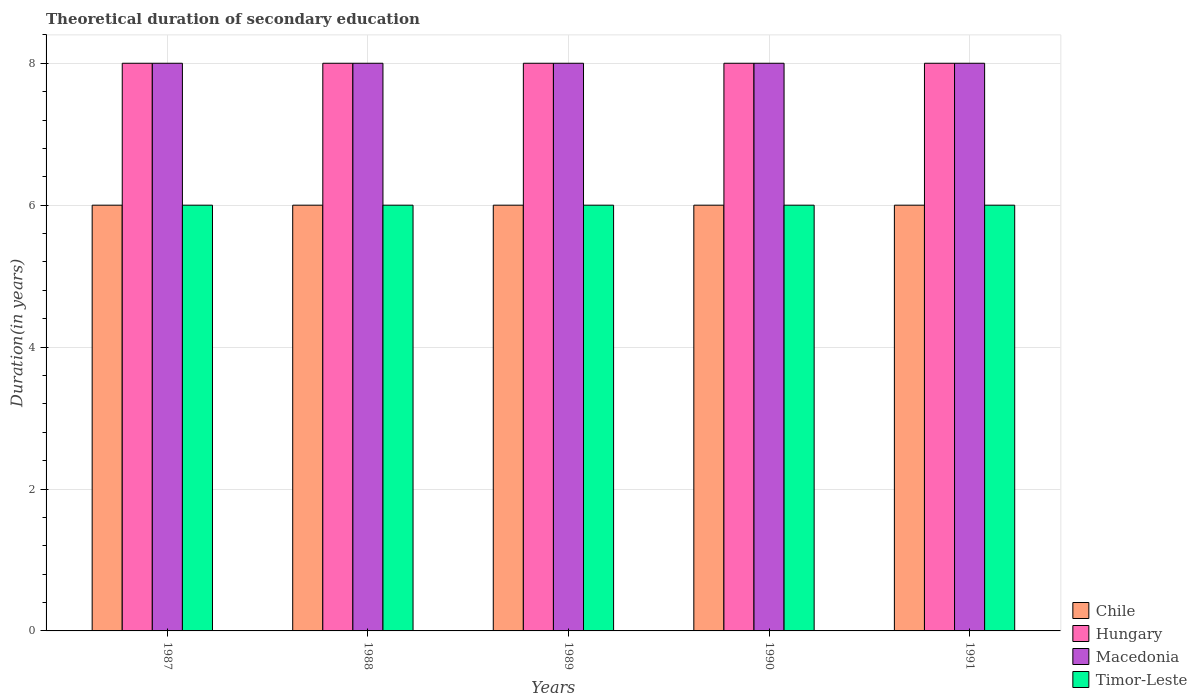How many groups of bars are there?
Give a very brief answer. 5. Are the number of bars per tick equal to the number of legend labels?
Your answer should be very brief. Yes. What is the label of the 4th group of bars from the left?
Offer a terse response. 1990. In how many cases, is the number of bars for a given year not equal to the number of legend labels?
Ensure brevity in your answer.  0. What is the total theoretical duration of secondary education in Timor-Leste in 1991?
Ensure brevity in your answer.  6. Across all years, what is the maximum total theoretical duration of secondary education in Macedonia?
Provide a short and direct response. 8. Across all years, what is the minimum total theoretical duration of secondary education in Hungary?
Ensure brevity in your answer.  8. In which year was the total theoretical duration of secondary education in Timor-Leste maximum?
Ensure brevity in your answer.  1987. In which year was the total theoretical duration of secondary education in Macedonia minimum?
Provide a short and direct response. 1987. What is the total total theoretical duration of secondary education in Macedonia in the graph?
Make the answer very short. 40. What is the difference between the total theoretical duration of secondary education in Macedonia in 1989 and the total theoretical duration of secondary education in Hungary in 1991?
Provide a succinct answer. 0. What is the ratio of the total theoretical duration of secondary education in Macedonia in 1989 to that in 1991?
Make the answer very short. 1. Is the total theoretical duration of secondary education in Hungary in 1987 less than that in 1988?
Offer a very short reply. No. Is the difference between the total theoretical duration of secondary education in Hungary in 1989 and 1991 greater than the difference between the total theoretical duration of secondary education in Macedonia in 1989 and 1991?
Offer a terse response. No. In how many years, is the total theoretical duration of secondary education in Chile greater than the average total theoretical duration of secondary education in Chile taken over all years?
Your answer should be compact. 0. Is it the case that in every year, the sum of the total theoretical duration of secondary education in Macedonia and total theoretical duration of secondary education in Hungary is greater than the sum of total theoretical duration of secondary education in Chile and total theoretical duration of secondary education in Timor-Leste?
Give a very brief answer. No. What does the 1st bar from the left in 1988 represents?
Offer a very short reply. Chile. What does the 1st bar from the right in 1988 represents?
Offer a terse response. Timor-Leste. Is it the case that in every year, the sum of the total theoretical duration of secondary education in Macedonia and total theoretical duration of secondary education in Hungary is greater than the total theoretical duration of secondary education in Chile?
Your answer should be very brief. Yes. How many bars are there?
Offer a terse response. 20. Are all the bars in the graph horizontal?
Keep it short and to the point. No. How many years are there in the graph?
Offer a very short reply. 5. What is the difference between two consecutive major ticks on the Y-axis?
Provide a succinct answer. 2. Are the values on the major ticks of Y-axis written in scientific E-notation?
Provide a succinct answer. No. Where does the legend appear in the graph?
Offer a terse response. Bottom right. How are the legend labels stacked?
Your response must be concise. Vertical. What is the title of the graph?
Give a very brief answer. Theoretical duration of secondary education. What is the label or title of the Y-axis?
Make the answer very short. Duration(in years). What is the Duration(in years) in Chile in 1987?
Your answer should be compact. 6. What is the Duration(in years) of Macedonia in 1987?
Give a very brief answer. 8. What is the Duration(in years) in Chile in 1988?
Your answer should be very brief. 6. What is the Duration(in years) in Macedonia in 1988?
Provide a short and direct response. 8. What is the Duration(in years) in Hungary in 1989?
Offer a terse response. 8. What is the Duration(in years) of Macedonia in 1989?
Your answer should be compact. 8. What is the Duration(in years) in Timor-Leste in 1989?
Your response must be concise. 6. What is the Duration(in years) of Chile in 1990?
Your answer should be compact. 6. What is the Duration(in years) in Macedonia in 1990?
Offer a terse response. 8. What is the Duration(in years) in Timor-Leste in 1990?
Provide a succinct answer. 6. What is the Duration(in years) of Timor-Leste in 1991?
Your answer should be very brief. 6. Across all years, what is the maximum Duration(in years) in Chile?
Offer a very short reply. 6. Across all years, what is the maximum Duration(in years) of Hungary?
Give a very brief answer. 8. Across all years, what is the minimum Duration(in years) of Macedonia?
Keep it short and to the point. 8. What is the total Duration(in years) in Macedonia in the graph?
Provide a succinct answer. 40. What is the difference between the Duration(in years) of Chile in 1987 and that in 1988?
Keep it short and to the point. 0. What is the difference between the Duration(in years) of Timor-Leste in 1987 and that in 1988?
Your answer should be very brief. 0. What is the difference between the Duration(in years) of Chile in 1987 and that in 1989?
Your response must be concise. 0. What is the difference between the Duration(in years) of Hungary in 1987 and that in 1989?
Ensure brevity in your answer.  0. What is the difference between the Duration(in years) of Chile in 1987 and that in 1990?
Your answer should be very brief. 0. What is the difference between the Duration(in years) in Macedonia in 1987 and that in 1990?
Offer a very short reply. 0. What is the difference between the Duration(in years) in Timor-Leste in 1987 and that in 1990?
Your answer should be very brief. 0. What is the difference between the Duration(in years) of Chile in 1987 and that in 1991?
Provide a short and direct response. 0. What is the difference between the Duration(in years) in Timor-Leste in 1987 and that in 1991?
Ensure brevity in your answer.  0. What is the difference between the Duration(in years) in Macedonia in 1988 and that in 1989?
Offer a terse response. 0. What is the difference between the Duration(in years) in Chile in 1988 and that in 1990?
Offer a terse response. 0. What is the difference between the Duration(in years) in Macedonia in 1988 and that in 1990?
Ensure brevity in your answer.  0. What is the difference between the Duration(in years) in Timor-Leste in 1988 and that in 1990?
Offer a very short reply. 0. What is the difference between the Duration(in years) in Hungary in 1989 and that in 1990?
Your answer should be compact. 0. What is the difference between the Duration(in years) of Chile in 1989 and that in 1991?
Give a very brief answer. 0. What is the difference between the Duration(in years) of Macedonia in 1989 and that in 1991?
Offer a terse response. 0. What is the difference between the Duration(in years) of Timor-Leste in 1989 and that in 1991?
Your response must be concise. 0. What is the difference between the Duration(in years) in Hungary in 1990 and that in 1991?
Keep it short and to the point. 0. What is the difference between the Duration(in years) of Macedonia in 1990 and that in 1991?
Provide a short and direct response. 0. What is the difference between the Duration(in years) in Timor-Leste in 1990 and that in 1991?
Ensure brevity in your answer.  0. What is the difference between the Duration(in years) of Chile in 1987 and the Duration(in years) of Hungary in 1988?
Keep it short and to the point. -2. What is the difference between the Duration(in years) in Chile in 1987 and the Duration(in years) in Macedonia in 1988?
Provide a succinct answer. -2. What is the difference between the Duration(in years) of Macedonia in 1987 and the Duration(in years) of Timor-Leste in 1988?
Keep it short and to the point. 2. What is the difference between the Duration(in years) of Macedonia in 1987 and the Duration(in years) of Timor-Leste in 1989?
Ensure brevity in your answer.  2. What is the difference between the Duration(in years) of Chile in 1987 and the Duration(in years) of Macedonia in 1990?
Give a very brief answer. -2. What is the difference between the Duration(in years) of Macedonia in 1987 and the Duration(in years) of Timor-Leste in 1990?
Your response must be concise. 2. What is the difference between the Duration(in years) of Hungary in 1987 and the Duration(in years) of Timor-Leste in 1991?
Offer a terse response. 2. What is the difference between the Duration(in years) of Chile in 1988 and the Duration(in years) of Hungary in 1989?
Your answer should be compact. -2. What is the difference between the Duration(in years) in Chile in 1988 and the Duration(in years) in Macedonia in 1989?
Ensure brevity in your answer.  -2. What is the difference between the Duration(in years) of Hungary in 1988 and the Duration(in years) of Timor-Leste in 1989?
Offer a very short reply. 2. What is the difference between the Duration(in years) of Chile in 1988 and the Duration(in years) of Hungary in 1990?
Ensure brevity in your answer.  -2. What is the difference between the Duration(in years) of Chile in 1988 and the Duration(in years) of Macedonia in 1990?
Make the answer very short. -2. What is the difference between the Duration(in years) of Chile in 1988 and the Duration(in years) of Timor-Leste in 1990?
Provide a short and direct response. 0. What is the difference between the Duration(in years) in Hungary in 1988 and the Duration(in years) in Timor-Leste in 1990?
Your response must be concise. 2. What is the difference between the Duration(in years) in Macedonia in 1988 and the Duration(in years) in Timor-Leste in 1990?
Make the answer very short. 2. What is the difference between the Duration(in years) in Hungary in 1988 and the Duration(in years) in Timor-Leste in 1991?
Your answer should be very brief. 2. What is the difference between the Duration(in years) of Macedonia in 1988 and the Duration(in years) of Timor-Leste in 1991?
Make the answer very short. 2. What is the difference between the Duration(in years) of Chile in 1989 and the Duration(in years) of Hungary in 1990?
Give a very brief answer. -2. What is the difference between the Duration(in years) of Chile in 1989 and the Duration(in years) of Macedonia in 1990?
Keep it short and to the point. -2. What is the difference between the Duration(in years) in Hungary in 1989 and the Duration(in years) in Timor-Leste in 1990?
Give a very brief answer. 2. What is the difference between the Duration(in years) in Macedonia in 1989 and the Duration(in years) in Timor-Leste in 1990?
Make the answer very short. 2. What is the difference between the Duration(in years) in Chile in 1989 and the Duration(in years) in Macedonia in 1991?
Your response must be concise. -2. What is the difference between the Duration(in years) of Chile in 1989 and the Duration(in years) of Timor-Leste in 1991?
Offer a terse response. 0. What is the difference between the Duration(in years) of Hungary in 1989 and the Duration(in years) of Timor-Leste in 1991?
Make the answer very short. 2. What is the difference between the Duration(in years) in Chile in 1990 and the Duration(in years) in Macedonia in 1991?
Ensure brevity in your answer.  -2. What is the difference between the Duration(in years) in Chile in 1990 and the Duration(in years) in Timor-Leste in 1991?
Your answer should be very brief. 0. What is the difference between the Duration(in years) in Hungary in 1990 and the Duration(in years) in Timor-Leste in 1991?
Provide a short and direct response. 2. In the year 1987, what is the difference between the Duration(in years) in Chile and Duration(in years) in Hungary?
Offer a very short reply. -2. In the year 1987, what is the difference between the Duration(in years) in Hungary and Duration(in years) in Macedonia?
Provide a succinct answer. 0. In the year 1987, what is the difference between the Duration(in years) in Hungary and Duration(in years) in Timor-Leste?
Keep it short and to the point. 2. In the year 1987, what is the difference between the Duration(in years) of Macedonia and Duration(in years) of Timor-Leste?
Provide a short and direct response. 2. In the year 1988, what is the difference between the Duration(in years) of Chile and Duration(in years) of Hungary?
Your answer should be compact. -2. In the year 1989, what is the difference between the Duration(in years) in Chile and Duration(in years) in Hungary?
Provide a short and direct response. -2. In the year 1989, what is the difference between the Duration(in years) in Chile and Duration(in years) in Macedonia?
Make the answer very short. -2. In the year 1989, what is the difference between the Duration(in years) in Chile and Duration(in years) in Timor-Leste?
Provide a short and direct response. 0. In the year 1989, what is the difference between the Duration(in years) of Hungary and Duration(in years) of Macedonia?
Offer a very short reply. 0. In the year 1990, what is the difference between the Duration(in years) of Chile and Duration(in years) of Hungary?
Make the answer very short. -2. In the year 1990, what is the difference between the Duration(in years) of Chile and Duration(in years) of Macedonia?
Your answer should be compact. -2. In the year 1990, what is the difference between the Duration(in years) of Hungary and Duration(in years) of Timor-Leste?
Provide a succinct answer. 2. In the year 1991, what is the difference between the Duration(in years) of Chile and Duration(in years) of Macedonia?
Your answer should be very brief. -2. In the year 1991, what is the difference between the Duration(in years) in Macedonia and Duration(in years) in Timor-Leste?
Ensure brevity in your answer.  2. What is the ratio of the Duration(in years) in Chile in 1987 to that in 1988?
Offer a terse response. 1. What is the ratio of the Duration(in years) of Hungary in 1987 to that in 1988?
Keep it short and to the point. 1. What is the ratio of the Duration(in years) of Macedonia in 1987 to that in 1988?
Offer a very short reply. 1. What is the ratio of the Duration(in years) of Timor-Leste in 1987 to that in 1988?
Provide a succinct answer. 1. What is the ratio of the Duration(in years) of Macedonia in 1987 to that in 1989?
Provide a short and direct response. 1. What is the ratio of the Duration(in years) of Hungary in 1987 to that in 1990?
Keep it short and to the point. 1. What is the ratio of the Duration(in years) of Timor-Leste in 1987 to that in 1990?
Offer a very short reply. 1. What is the ratio of the Duration(in years) in Hungary in 1987 to that in 1991?
Your answer should be very brief. 1. What is the ratio of the Duration(in years) of Macedonia in 1987 to that in 1991?
Make the answer very short. 1. What is the ratio of the Duration(in years) of Hungary in 1988 to that in 1989?
Offer a very short reply. 1. What is the ratio of the Duration(in years) of Macedonia in 1988 to that in 1989?
Offer a very short reply. 1. What is the ratio of the Duration(in years) of Hungary in 1988 to that in 1990?
Make the answer very short. 1. What is the ratio of the Duration(in years) of Chile in 1988 to that in 1991?
Provide a short and direct response. 1. What is the ratio of the Duration(in years) in Hungary in 1988 to that in 1991?
Provide a succinct answer. 1. What is the ratio of the Duration(in years) of Timor-Leste in 1988 to that in 1991?
Your answer should be compact. 1. What is the ratio of the Duration(in years) in Chile in 1989 to that in 1990?
Your answer should be compact. 1. What is the ratio of the Duration(in years) in Timor-Leste in 1989 to that in 1990?
Provide a short and direct response. 1. What is the ratio of the Duration(in years) of Chile in 1989 to that in 1991?
Give a very brief answer. 1. What is the ratio of the Duration(in years) of Hungary in 1989 to that in 1991?
Offer a terse response. 1. What is the ratio of the Duration(in years) in Macedonia in 1989 to that in 1991?
Give a very brief answer. 1. What is the difference between the highest and the second highest Duration(in years) in Chile?
Provide a short and direct response. 0. What is the difference between the highest and the second highest Duration(in years) of Macedonia?
Provide a succinct answer. 0. What is the difference between the highest and the second highest Duration(in years) in Timor-Leste?
Give a very brief answer. 0. What is the difference between the highest and the lowest Duration(in years) of Hungary?
Offer a very short reply. 0. 